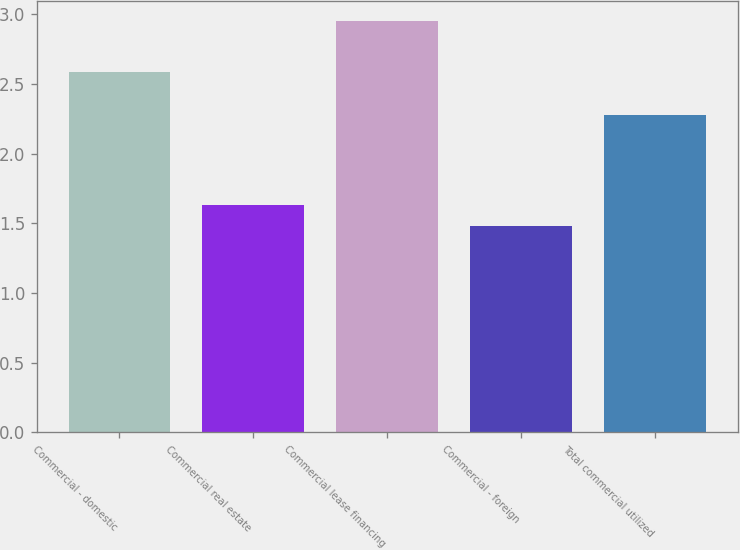<chart> <loc_0><loc_0><loc_500><loc_500><bar_chart><fcel>Commercial - domestic<fcel>Commercial real estate<fcel>Commercial lease financing<fcel>Commercial - foreign<fcel>Total commercial utilized<nl><fcel>2.59<fcel>1.63<fcel>2.95<fcel>1.48<fcel>2.28<nl></chart> 